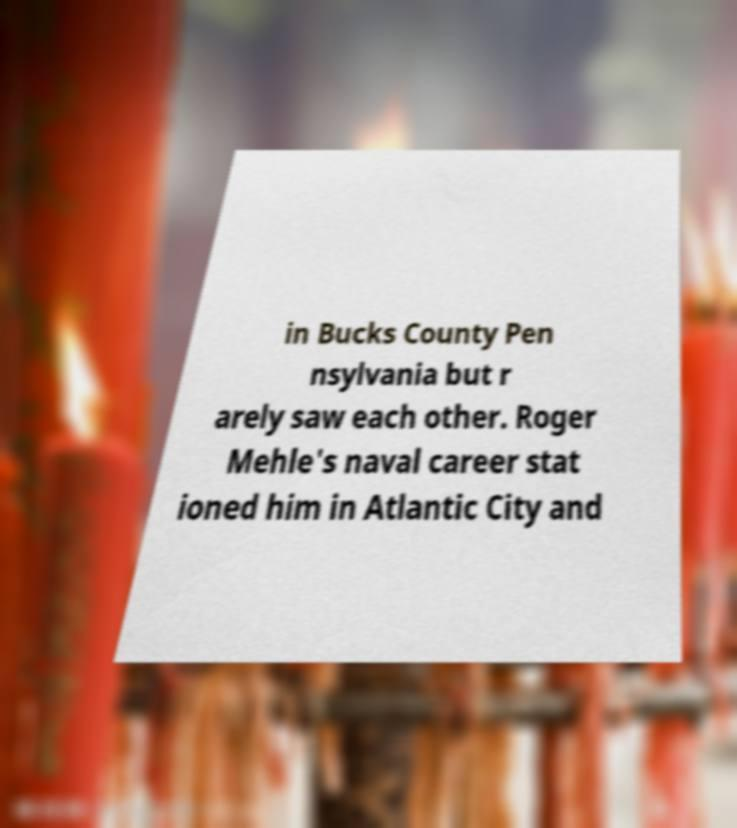There's text embedded in this image that I need extracted. Can you transcribe it verbatim? in Bucks County Pen nsylvania but r arely saw each other. Roger Mehle's naval career stat ioned him in Atlantic City and 